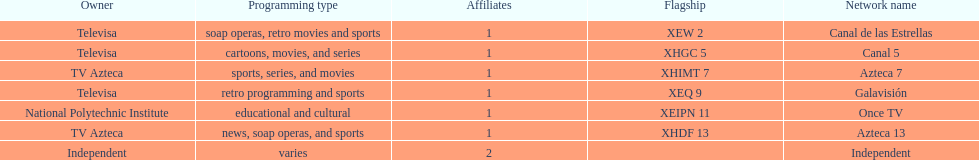Could you help me parse every detail presented in this table? {'header': ['Owner', 'Programming type', 'Affiliates', 'Flagship', 'Network name'], 'rows': [['Televisa', 'soap operas, retro movies and sports', '1', 'XEW 2', 'Canal de las Estrellas'], ['Televisa', 'cartoons, movies, and series', '1', 'XHGC 5', 'Canal 5'], ['TV Azteca', 'sports, series, and movies', '1', 'XHIMT 7', 'Azteca 7'], ['Televisa', 'retro programming and sports', '1', 'XEQ 9', 'Galavisión'], ['National Polytechnic Institute', 'educational and cultural', '1', 'XEIPN 11', 'Once TV'], ['TV Azteca', 'news, soap operas, and sports', '1', 'XHDF 13', 'Azteca 13'], ['Independent', 'varies', '2', '', 'Independent']]} What is the number of networks that are owned by televisa? 3. 